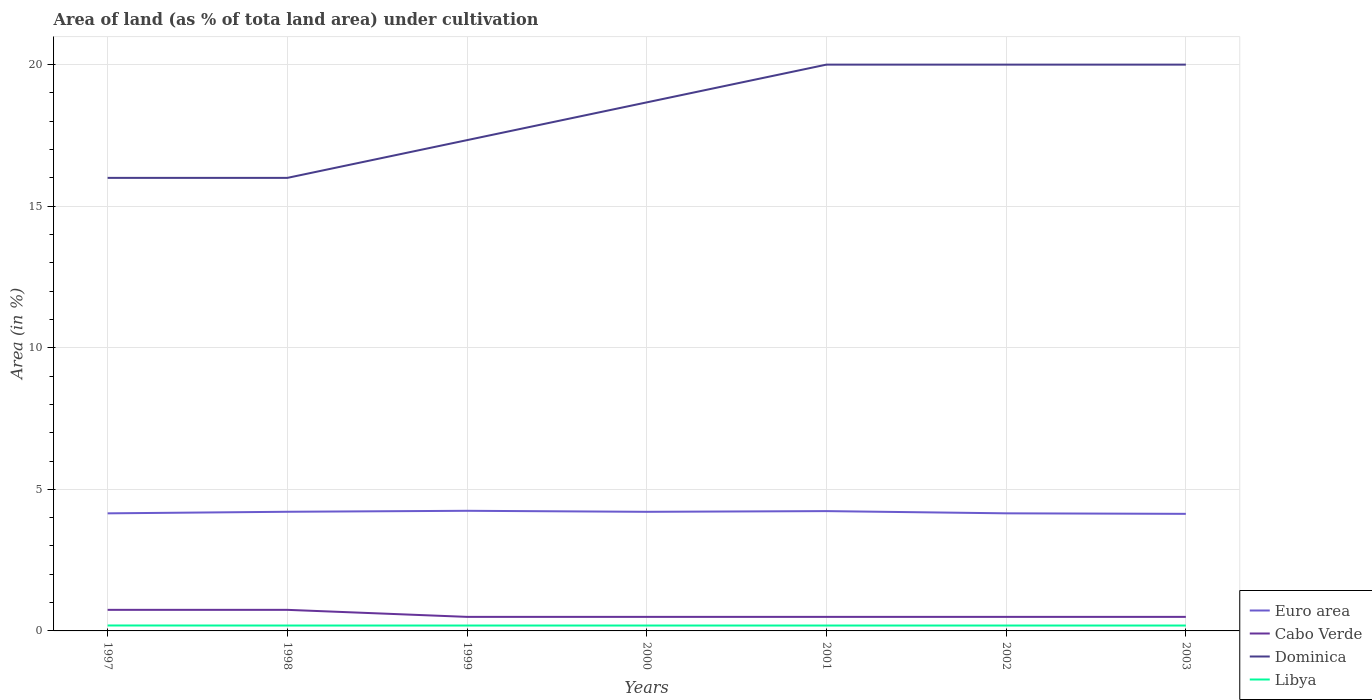Does the line corresponding to Dominica intersect with the line corresponding to Libya?
Your answer should be compact. No. Is the number of lines equal to the number of legend labels?
Offer a very short reply. Yes. Across all years, what is the maximum percentage of land under cultivation in Libya?
Your answer should be compact. 0.19. What is the total percentage of land under cultivation in Euro area in the graph?
Provide a succinct answer. -0.09. What is the difference between the highest and the second highest percentage of land under cultivation in Libya?
Offer a very short reply. 0. What is the difference between the highest and the lowest percentage of land under cultivation in Euro area?
Your answer should be very brief. 4. Is the percentage of land under cultivation in Euro area strictly greater than the percentage of land under cultivation in Libya over the years?
Your response must be concise. No. What is the difference between two consecutive major ticks on the Y-axis?
Keep it short and to the point. 5. Are the values on the major ticks of Y-axis written in scientific E-notation?
Your answer should be compact. No. Does the graph contain any zero values?
Your response must be concise. No. Does the graph contain grids?
Offer a very short reply. Yes. How many legend labels are there?
Provide a succinct answer. 4. What is the title of the graph?
Provide a short and direct response. Area of land (as % of tota land area) under cultivation. Does "Isle of Man" appear as one of the legend labels in the graph?
Offer a very short reply. No. What is the label or title of the X-axis?
Your answer should be very brief. Years. What is the label or title of the Y-axis?
Provide a short and direct response. Area (in %). What is the Area (in %) of Euro area in 1997?
Give a very brief answer. 4.15. What is the Area (in %) of Cabo Verde in 1997?
Offer a very short reply. 0.74. What is the Area (in %) of Dominica in 1997?
Offer a terse response. 16. What is the Area (in %) of Libya in 1997?
Ensure brevity in your answer.  0.19. What is the Area (in %) of Euro area in 1998?
Ensure brevity in your answer.  4.21. What is the Area (in %) in Cabo Verde in 1998?
Your response must be concise. 0.74. What is the Area (in %) in Dominica in 1998?
Ensure brevity in your answer.  16. What is the Area (in %) of Libya in 1998?
Offer a very short reply. 0.19. What is the Area (in %) in Euro area in 1999?
Your response must be concise. 4.24. What is the Area (in %) in Cabo Verde in 1999?
Give a very brief answer. 0.5. What is the Area (in %) in Dominica in 1999?
Offer a very short reply. 17.33. What is the Area (in %) of Libya in 1999?
Provide a succinct answer. 0.19. What is the Area (in %) in Euro area in 2000?
Offer a terse response. 4.21. What is the Area (in %) in Cabo Verde in 2000?
Your answer should be compact. 0.5. What is the Area (in %) in Dominica in 2000?
Provide a succinct answer. 18.67. What is the Area (in %) in Libya in 2000?
Your response must be concise. 0.19. What is the Area (in %) in Euro area in 2001?
Keep it short and to the point. 4.23. What is the Area (in %) of Cabo Verde in 2001?
Make the answer very short. 0.5. What is the Area (in %) of Libya in 2001?
Offer a very short reply. 0.19. What is the Area (in %) of Euro area in 2002?
Your answer should be very brief. 4.15. What is the Area (in %) of Cabo Verde in 2002?
Make the answer very short. 0.5. What is the Area (in %) in Libya in 2002?
Offer a very short reply. 0.19. What is the Area (in %) in Euro area in 2003?
Your answer should be compact. 4.14. What is the Area (in %) in Cabo Verde in 2003?
Keep it short and to the point. 0.5. What is the Area (in %) in Libya in 2003?
Provide a short and direct response. 0.19. Across all years, what is the maximum Area (in %) in Euro area?
Offer a very short reply. 4.24. Across all years, what is the maximum Area (in %) in Cabo Verde?
Offer a very short reply. 0.74. Across all years, what is the maximum Area (in %) of Libya?
Provide a short and direct response. 0.19. Across all years, what is the minimum Area (in %) in Euro area?
Keep it short and to the point. 4.14. Across all years, what is the minimum Area (in %) of Cabo Verde?
Provide a succinct answer. 0.5. Across all years, what is the minimum Area (in %) of Dominica?
Provide a short and direct response. 16. Across all years, what is the minimum Area (in %) of Libya?
Make the answer very short. 0.19. What is the total Area (in %) of Euro area in the graph?
Your response must be concise. 29.33. What is the total Area (in %) of Cabo Verde in the graph?
Your answer should be very brief. 3.97. What is the total Area (in %) of Dominica in the graph?
Provide a succinct answer. 128. What is the total Area (in %) in Libya in the graph?
Offer a very short reply. 1.33. What is the difference between the Area (in %) in Euro area in 1997 and that in 1998?
Offer a very short reply. -0.06. What is the difference between the Area (in %) of Libya in 1997 and that in 1998?
Your answer should be compact. 0. What is the difference between the Area (in %) in Euro area in 1997 and that in 1999?
Provide a succinct answer. -0.09. What is the difference between the Area (in %) of Cabo Verde in 1997 and that in 1999?
Offer a very short reply. 0.25. What is the difference between the Area (in %) of Dominica in 1997 and that in 1999?
Ensure brevity in your answer.  -1.33. What is the difference between the Area (in %) of Libya in 1997 and that in 1999?
Offer a very short reply. 0. What is the difference between the Area (in %) in Euro area in 1997 and that in 2000?
Make the answer very short. -0.05. What is the difference between the Area (in %) in Cabo Verde in 1997 and that in 2000?
Offer a very short reply. 0.25. What is the difference between the Area (in %) of Dominica in 1997 and that in 2000?
Keep it short and to the point. -2.67. What is the difference between the Area (in %) in Libya in 1997 and that in 2000?
Keep it short and to the point. 0. What is the difference between the Area (in %) of Euro area in 1997 and that in 2001?
Your response must be concise. -0.08. What is the difference between the Area (in %) in Cabo Verde in 1997 and that in 2001?
Provide a short and direct response. 0.25. What is the difference between the Area (in %) in Dominica in 1997 and that in 2001?
Offer a very short reply. -4. What is the difference between the Area (in %) in Libya in 1997 and that in 2001?
Your response must be concise. 0. What is the difference between the Area (in %) in Euro area in 1997 and that in 2002?
Keep it short and to the point. -0. What is the difference between the Area (in %) of Cabo Verde in 1997 and that in 2002?
Your response must be concise. 0.25. What is the difference between the Area (in %) in Dominica in 1997 and that in 2002?
Your response must be concise. -4. What is the difference between the Area (in %) of Libya in 1997 and that in 2002?
Provide a short and direct response. 0. What is the difference between the Area (in %) in Euro area in 1997 and that in 2003?
Provide a short and direct response. 0.02. What is the difference between the Area (in %) in Cabo Verde in 1997 and that in 2003?
Make the answer very short. 0.25. What is the difference between the Area (in %) in Dominica in 1997 and that in 2003?
Give a very brief answer. -4. What is the difference between the Area (in %) of Libya in 1997 and that in 2003?
Offer a very short reply. 0. What is the difference between the Area (in %) in Euro area in 1998 and that in 1999?
Your answer should be very brief. -0.03. What is the difference between the Area (in %) in Cabo Verde in 1998 and that in 1999?
Give a very brief answer. 0.25. What is the difference between the Area (in %) of Dominica in 1998 and that in 1999?
Offer a very short reply. -1.33. What is the difference between the Area (in %) in Euro area in 1998 and that in 2000?
Offer a terse response. 0. What is the difference between the Area (in %) of Cabo Verde in 1998 and that in 2000?
Your answer should be very brief. 0.25. What is the difference between the Area (in %) in Dominica in 1998 and that in 2000?
Your response must be concise. -2.67. What is the difference between the Area (in %) of Libya in 1998 and that in 2000?
Offer a very short reply. 0. What is the difference between the Area (in %) in Euro area in 1998 and that in 2001?
Provide a short and direct response. -0.02. What is the difference between the Area (in %) in Cabo Verde in 1998 and that in 2001?
Your response must be concise. 0.25. What is the difference between the Area (in %) of Euro area in 1998 and that in 2002?
Offer a terse response. 0.06. What is the difference between the Area (in %) of Cabo Verde in 1998 and that in 2002?
Your answer should be very brief. 0.25. What is the difference between the Area (in %) in Euro area in 1998 and that in 2003?
Provide a succinct answer. 0.07. What is the difference between the Area (in %) of Cabo Verde in 1998 and that in 2003?
Your response must be concise. 0.25. What is the difference between the Area (in %) in Euro area in 1999 and that in 2000?
Your response must be concise. 0.04. What is the difference between the Area (in %) in Dominica in 1999 and that in 2000?
Your response must be concise. -1.33. What is the difference between the Area (in %) in Euro area in 1999 and that in 2001?
Make the answer very short. 0.01. What is the difference between the Area (in %) in Dominica in 1999 and that in 2001?
Ensure brevity in your answer.  -2.67. What is the difference between the Area (in %) in Libya in 1999 and that in 2001?
Give a very brief answer. 0. What is the difference between the Area (in %) of Euro area in 1999 and that in 2002?
Ensure brevity in your answer.  0.09. What is the difference between the Area (in %) in Cabo Verde in 1999 and that in 2002?
Make the answer very short. 0. What is the difference between the Area (in %) of Dominica in 1999 and that in 2002?
Offer a terse response. -2.67. What is the difference between the Area (in %) in Euro area in 1999 and that in 2003?
Ensure brevity in your answer.  0.11. What is the difference between the Area (in %) of Cabo Verde in 1999 and that in 2003?
Make the answer very short. 0. What is the difference between the Area (in %) of Dominica in 1999 and that in 2003?
Provide a succinct answer. -2.67. What is the difference between the Area (in %) of Libya in 1999 and that in 2003?
Ensure brevity in your answer.  0. What is the difference between the Area (in %) of Euro area in 2000 and that in 2001?
Ensure brevity in your answer.  -0.02. What is the difference between the Area (in %) in Cabo Verde in 2000 and that in 2001?
Keep it short and to the point. 0. What is the difference between the Area (in %) in Dominica in 2000 and that in 2001?
Make the answer very short. -1.33. What is the difference between the Area (in %) of Libya in 2000 and that in 2001?
Make the answer very short. 0. What is the difference between the Area (in %) of Euro area in 2000 and that in 2002?
Your response must be concise. 0.05. What is the difference between the Area (in %) of Cabo Verde in 2000 and that in 2002?
Provide a succinct answer. 0. What is the difference between the Area (in %) in Dominica in 2000 and that in 2002?
Your answer should be compact. -1.33. What is the difference between the Area (in %) of Euro area in 2000 and that in 2003?
Provide a short and direct response. 0.07. What is the difference between the Area (in %) in Cabo Verde in 2000 and that in 2003?
Provide a short and direct response. 0. What is the difference between the Area (in %) in Dominica in 2000 and that in 2003?
Ensure brevity in your answer.  -1.33. What is the difference between the Area (in %) of Euro area in 2001 and that in 2002?
Make the answer very short. 0.08. What is the difference between the Area (in %) of Dominica in 2001 and that in 2002?
Provide a succinct answer. 0. What is the difference between the Area (in %) in Libya in 2001 and that in 2002?
Keep it short and to the point. 0. What is the difference between the Area (in %) of Euro area in 2001 and that in 2003?
Keep it short and to the point. 0.1. What is the difference between the Area (in %) of Cabo Verde in 2001 and that in 2003?
Your response must be concise. 0. What is the difference between the Area (in %) in Euro area in 2002 and that in 2003?
Offer a very short reply. 0.02. What is the difference between the Area (in %) of Dominica in 2002 and that in 2003?
Provide a succinct answer. 0. What is the difference between the Area (in %) in Libya in 2002 and that in 2003?
Your answer should be very brief. 0. What is the difference between the Area (in %) of Euro area in 1997 and the Area (in %) of Cabo Verde in 1998?
Provide a succinct answer. 3.41. What is the difference between the Area (in %) in Euro area in 1997 and the Area (in %) in Dominica in 1998?
Your answer should be compact. -11.85. What is the difference between the Area (in %) of Euro area in 1997 and the Area (in %) of Libya in 1998?
Make the answer very short. 3.96. What is the difference between the Area (in %) of Cabo Verde in 1997 and the Area (in %) of Dominica in 1998?
Give a very brief answer. -15.26. What is the difference between the Area (in %) in Cabo Verde in 1997 and the Area (in %) in Libya in 1998?
Provide a short and direct response. 0.55. What is the difference between the Area (in %) in Dominica in 1997 and the Area (in %) in Libya in 1998?
Your answer should be very brief. 15.81. What is the difference between the Area (in %) in Euro area in 1997 and the Area (in %) in Cabo Verde in 1999?
Provide a succinct answer. 3.66. What is the difference between the Area (in %) in Euro area in 1997 and the Area (in %) in Dominica in 1999?
Provide a succinct answer. -13.18. What is the difference between the Area (in %) in Euro area in 1997 and the Area (in %) in Libya in 1999?
Offer a terse response. 3.96. What is the difference between the Area (in %) in Cabo Verde in 1997 and the Area (in %) in Dominica in 1999?
Offer a terse response. -16.59. What is the difference between the Area (in %) in Cabo Verde in 1997 and the Area (in %) in Libya in 1999?
Offer a terse response. 0.55. What is the difference between the Area (in %) of Dominica in 1997 and the Area (in %) of Libya in 1999?
Your answer should be very brief. 15.81. What is the difference between the Area (in %) in Euro area in 1997 and the Area (in %) in Cabo Verde in 2000?
Your answer should be very brief. 3.66. What is the difference between the Area (in %) of Euro area in 1997 and the Area (in %) of Dominica in 2000?
Offer a very short reply. -14.51. What is the difference between the Area (in %) in Euro area in 1997 and the Area (in %) in Libya in 2000?
Your answer should be very brief. 3.96. What is the difference between the Area (in %) of Cabo Verde in 1997 and the Area (in %) of Dominica in 2000?
Give a very brief answer. -17.92. What is the difference between the Area (in %) of Cabo Verde in 1997 and the Area (in %) of Libya in 2000?
Ensure brevity in your answer.  0.55. What is the difference between the Area (in %) in Dominica in 1997 and the Area (in %) in Libya in 2000?
Your answer should be very brief. 15.81. What is the difference between the Area (in %) in Euro area in 1997 and the Area (in %) in Cabo Verde in 2001?
Ensure brevity in your answer.  3.66. What is the difference between the Area (in %) in Euro area in 1997 and the Area (in %) in Dominica in 2001?
Provide a short and direct response. -15.85. What is the difference between the Area (in %) of Euro area in 1997 and the Area (in %) of Libya in 2001?
Provide a short and direct response. 3.96. What is the difference between the Area (in %) of Cabo Verde in 1997 and the Area (in %) of Dominica in 2001?
Offer a terse response. -19.26. What is the difference between the Area (in %) in Cabo Verde in 1997 and the Area (in %) in Libya in 2001?
Keep it short and to the point. 0.55. What is the difference between the Area (in %) of Dominica in 1997 and the Area (in %) of Libya in 2001?
Provide a short and direct response. 15.81. What is the difference between the Area (in %) in Euro area in 1997 and the Area (in %) in Cabo Verde in 2002?
Keep it short and to the point. 3.66. What is the difference between the Area (in %) of Euro area in 1997 and the Area (in %) of Dominica in 2002?
Your answer should be very brief. -15.85. What is the difference between the Area (in %) of Euro area in 1997 and the Area (in %) of Libya in 2002?
Provide a short and direct response. 3.96. What is the difference between the Area (in %) of Cabo Verde in 1997 and the Area (in %) of Dominica in 2002?
Keep it short and to the point. -19.26. What is the difference between the Area (in %) in Cabo Verde in 1997 and the Area (in %) in Libya in 2002?
Offer a terse response. 0.55. What is the difference between the Area (in %) in Dominica in 1997 and the Area (in %) in Libya in 2002?
Offer a very short reply. 15.81. What is the difference between the Area (in %) in Euro area in 1997 and the Area (in %) in Cabo Verde in 2003?
Offer a terse response. 3.66. What is the difference between the Area (in %) of Euro area in 1997 and the Area (in %) of Dominica in 2003?
Keep it short and to the point. -15.85. What is the difference between the Area (in %) in Euro area in 1997 and the Area (in %) in Libya in 2003?
Make the answer very short. 3.96. What is the difference between the Area (in %) in Cabo Verde in 1997 and the Area (in %) in Dominica in 2003?
Your answer should be compact. -19.26. What is the difference between the Area (in %) in Cabo Verde in 1997 and the Area (in %) in Libya in 2003?
Offer a terse response. 0.55. What is the difference between the Area (in %) in Dominica in 1997 and the Area (in %) in Libya in 2003?
Ensure brevity in your answer.  15.81. What is the difference between the Area (in %) of Euro area in 1998 and the Area (in %) of Cabo Verde in 1999?
Ensure brevity in your answer.  3.71. What is the difference between the Area (in %) of Euro area in 1998 and the Area (in %) of Dominica in 1999?
Give a very brief answer. -13.12. What is the difference between the Area (in %) in Euro area in 1998 and the Area (in %) in Libya in 1999?
Your response must be concise. 4.02. What is the difference between the Area (in %) of Cabo Verde in 1998 and the Area (in %) of Dominica in 1999?
Your response must be concise. -16.59. What is the difference between the Area (in %) in Cabo Verde in 1998 and the Area (in %) in Libya in 1999?
Offer a terse response. 0.55. What is the difference between the Area (in %) in Dominica in 1998 and the Area (in %) in Libya in 1999?
Provide a succinct answer. 15.81. What is the difference between the Area (in %) of Euro area in 1998 and the Area (in %) of Cabo Verde in 2000?
Make the answer very short. 3.71. What is the difference between the Area (in %) in Euro area in 1998 and the Area (in %) in Dominica in 2000?
Keep it short and to the point. -14.46. What is the difference between the Area (in %) in Euro area in 1998 and the Area (in %) in Libya in 2000?
Make the answer very short. 4.02. What is the difference between the Area (in %) of Cabo Verde in 1998 and the Area (in %) of Dominica in 2000?
Offer a terse response. -17.92. What is the difference between the Area (in %) in Cabo Verde in 1998 and the Area (in %) in Libya in 2000?
Make the answer very short. 0.55. What is the difference between the Area (in %) of Dominica in 1998 and the Area (in %) of Libya in 2000?
Your answer should be very brief. 15.81. What is the difference between the Area (in %) in Euro area in 1998 and the Area (in %) in Cabo Verde in 2001?
Provide a short and direct response. 3.71. What is the difference between the Area (in %) in Euro area in 1998 and the Area (in %) in Dominica in 2001?
Provide a short and direct response. -15.79. What is the difference between the Area (in %) of Euro area in 1998 and the Area (in %) of Libya in 2001?
Offer a terse response. 4.02. What is the difference between the Area (in %) in Cabo Verde in 1998 and the Area (in %) in Dominica in 2001?
Your response must be concise. -19.26. What is the difference between the Area (in %) of Cabo Verde in 1998 and the Area (in %) of Libya in 2001?
Make the answer very short. 0.55. What is the difference between the Area (in %) of Dominica in 1998 and the Area (in %) of Libya in 2001?
Your answer should be compact. 15.81. What is the difference between the Area (in %) in Euro area in 1998 and the Area (in %) in Cabo Verde in 2002?
Provide a succinct answer. 3.71. What is the difference between the Area (in %) of Euro area in 1998 and the Area (in %) of Dominica in 2002?
Your answer should be very brief. -15.79. What is the difference between the Area (in %) of Euro area in 1998 and the Area (in %) of Libya in 2002?
Your answer should be compact. 4.02. What is the difference between the Area (in %) of Cabo Verde in 1998 and the Area (in %) of Dominica in 2002?
Provide a short and direct response. -19.26. What is the difference between the Area (in %) in Cabo Verde in 1998 and the Area (in %) in Libya in 2002?
Offer a terse response. 0.55. What is the difference between the Area (in %) of Dominica in 1998 and the Area (in %) of Libya in 2002?
Your response must be concise. 15.81. What is the difference between the Area (in %) of Euro area in 1998 and the Area (in %) of Cabo Verde in 2003?
Offer a very short reply. 3.71. What is the difference between the Area (in %) of Euro area in 1998 and the Area (in %) of Dominica in 2003?
Your answer should be very brief. -15.79. What is the difference between the Area (in %) in Euro area in 1998 and the Area (in %) in Libya in 2003?
Your answer should be compact. 4.02. What is the difference between the Area (in %) of Cabo Verde in 1998 and the Area (in %) of Dominica in 2003?
Offer a terse response. -19.26. What is the difference between the Area (in %) in Cabo Verde in 1998 and the Area (in %) in Libya in 2003?
Offer a terse response. 0.55. What is the difference between the Area (in %) of Dominica in 1998 and the Area (in %) of Libya in 2003?
Your response must be concise. 15.81. What is the difference between the Area (in %) in Euro area in 1999 and the Area (in %) in Cabo Verde in 2000?
Provide a short and direct response. 3.75. What is the difference between the Area (in %) of Euro area in 1999 and the Area (in %) of Dominica in 2000?
Make the answer very short. -14.42. What is the difference between the Area (in %) of Euro area in 1999 and the Area (in %) of Libya in 2000?
Make the answer very short. 4.05. What is the difference between the Area (in %) in Cabo Verde in 1999 and the Area (in %) in Dominica in 2000?
Make the answer very short. -18.17. What is the difference between the Area (in %) of Cabo Verde in 1999 and the Area (in %) of Libya in 2000?
Give a very brief answer. 0.31. What is the difference between the Area (in %) of Dominica in 1999 and the Area (in %) of Libya in 2000?
Keep it short and to the point. 17.14. What is the difference between the Area (in %) of Euro area in 1999 and the Area (in %) of Cabo Verde in 2001?
Ensure brevity in your answer.  3.75. What is the difference between the Area (in %) of Euro area in 1999 and the Area (in %) of Dominica in 2001?
Provide a succinct answer. -15.76. What is the difference between the Area (in %) of Euro area in 1999 and the Area (in %) of Libya in 2001?
Your answer should be very brief. 4.05. What is the difference between the Area (in %) in Cabo Verde in 1999 and the Area (in %) in Dominica in 2001?
Ensure brevity in your answer.  -19.5. What is the difference between the Area (in %) in Cabo Verde in 1999 and the Area (in %) in Libya in 2001?
Offer a very short reply. 0.31. What is the difference between the Area (in %) in Dominica in 1999 and the Area (in %) in Libya in 2001?
Ensure brevity in your answer.  17.14. What is the difference between the Area (in %) in Euro area in 1999 and the Area (in %) in Cabo Verde in 2002?
Keep it short and to the point. 3.75. What is the difference between the Area (in %) in Euro area in 1999 and the Area (in %) in Dominica in 2002?
Provide a short and direct response. -15.76. What is the difference between the Area (in %) of Euro area in 1999 and the Area (in %) of Libya in 2002?
Keep it short and to the point. 4.05. What is the difference between the Area (in %) of Cabo Verde in 1999 and the Area (in %) of Dominica in 2002?
Your response must be concise. -19.5. What is the difference between the Area (in %) in Cabo Verde in 1999 and the Area (in %) in Libya in 2002?
Give a very brief answer. 0.31. What is the difference between the Area (in %) in Dominica in 1999 and the Area (in %) in Libya in 2002?
Offer a terse response. 17.14. What is the difference between the Area (in %) of Euro area in 1999 and the Area (in %) of Cabo Verde in 2003?
Make the answer very short. 3.75. What is the difference between the Area (in %) of Euro area in 1999 and the Area (in %) of Dominica in 2003?
Provide a short and direct response. -15.76. What is the difference between the Area (in %) in Euro area in 1999 and the Area (in %) in Libya in 2003?
Keep it short and to the point. 4.05. What is the difference between the Area (in %) in Cabo Verde in 1999 and the Area (in %) in Dominica in 2003?
Your response must be concise. -19.5. What is the difference between the Area (in %) in Cabo Verde in 1999 and the Area (in %) in Libya in 2003?
Your answer should be very brief. 0.31. What is the difference between the Area (in %) in Dominica in 1999 and the Area (in %) in Libya in 2003?
Your response must be concise. 17.14. What is the difference between the Area (in %) of Euro area in 2000 and the Area (in %) of Cabo Verde in 2001?
Your answer should be very brief. 3.71. What is the difference between the Area (in %) in Euro area in 2000 and the Area (in %) in Dominica in 2001?
Your response must be concise. -15.79. What is the difference between the Area (in %) of Euro area in 2000 and the Area (in %) of Libya in 2001?
Your response must be concise. 4.02. What is the difference between the Area (in %) in Cabo Verde in 2000 and the Area (in %) in Dominica in 2001?
Offer a terse response. -19.5. What is the difference between the Area (in %) in Cabo Verde in 2000 and the Area (in %) in Libya in 2001?
Provide a succinct answer. 0.31. What is the difference between the Area (in %) in Dominica in 2000 and the Area (in %) in Libya in 2001?
Keep it short and to the point. 18.48. What is the difference between the Area (in %) of Euro area in 2000 and the Area (in %) of Cabo Verde in 2002?
Offer a very short reply. 3.71. What is the difference between the Area (in %) of Euro area in 2000 and the Area (in %) of Dominica in 2002?
Keep it short and to the point. -15.79. What is the difference between the Area (in %) in Euro area in 2000 and the Area (in %) in Libya in 2002?
Give a very brief answer. 4.02. What is the difference between the Area (in %) of Cabo Verde in 2000 and the Area (in %) of Dominica in 2002?
Offer a very short reply. -19.5. What is the difference between the Area (in %) of Cabo Verde in 2000 and the Area (in %) of Libya in 2002?
Your answer should be compact. 0.31. What is the difference between the Area (in %) in Dominica in 2000 and the Area (in %) in Libya in 2002?
Your answer should be compact. 18.48. What is the difference between the Area (in %) of Euro area in 2000 and the Area (in %) of Cabo Verde in 2003?
Your answer should be compact. 3.71. What is the difference between the Area (in %) in Euro area in 2000 and the Area (in %) in Dominica in 2003?
Your answer should be very brief. -15.79. What is the difference between the Area (in %) in Euro area in 2000 and the Area (in %) in Libya in 2003?
Offer a very short reply. 4.02. What is the difference between the Area (in %) in Cabo Verde in 2000 and the Area (in %) in Dominica in 2003?
Make the answer very short. -19.5. What is the difference between the Area (in %) in Cabo Verde in 2000 and the Area (in %) in Libya in 2003?
Ensure brevity in your answer.  0.31. What is the difference between the Area (in %) in Dominica in 2000 and the Area (in %) in Libya in 2003?
Offer a very short reply. 18.48. What is the difference between the Area (in %) in Euro area in 2001 and the Area (in %) in Cabo Verde in 2002?
Give a very brief answer. 3.74. What is the difference between the Area (in %) of Euro area in 2001 and the Area (in %) of Dominica in 2002?
Give a very brief answer. -15.77. What is the difference between the Area (in %) of Euro area in 2001 and the Area (in %) of Libya in 2002?
Provide a succinct answer. 4.04. What is the difference between the Area (in %) in Cabo Verde in 2001 and the Area (in %) in Dominica in 2002?
Your answer should be compact. -19.5. What is the difference between the Area (in %) in Cabo Verde in 2001 and the Area (in %) in Libya in 2002?
Your answer should be very brief. 0.31. What is the difference between the Area (in %) in Dominica in 2001 and the Area (in %) in Libya in 2002?
Give a very brief answer. 19.81. What is the difference between the Area (in %) of Euro area in 2001 and the Area (in %) of Cabo Verde in 2003?
Your answer should be very brief. 3.74. What is the difference between the Area (in %) of Euro area in 2001 and the Area (in %) of Dominica in 2003?
Your answer should be very brief. -15.77. What is the difference between the Area (in %) in Euro area in 2001 and the Area (in %) in Libya in 2003?
Your answer should be very brief. 4.04. What is the difference between the Area (in %) of Cabo Verde in 2001 and the Area (in %) of Dominica in 2003?
Give a very brief answer. -19.5. What is the difference between the Area (in %) of Cabo Verde in 2001 and the Area (in %) of Libya in 2003?
Keep it short and to the point. 0.31. What is the difference between the Area (in %) in Dominica in 2001 and the Area (in %) in Libya in 2003?
Provide a short and direct response. 19.81. What is the difference between the Area (in %) in Euro area in 2002 and the Area (in %) in Cabo Verde in 2003?
Your answer should be compact. 3.66. What is the difference between the Area (in %) in Euro area in 2002 and the Area (in %) in Dominica in 2003?
Keep it short and to the point. -15.85. What is the difference between the Area (in %) of Euro area in 2002 and the Area (in %) of Libya in 2003?
Your answer should be very brief. 3.96. What is the difference between the Area (in %) in Cabo Verde in 2002 and the Area (in %) in Dominica in 2003?
Make the answer very short. -19.5. What is the difference between the Area (in %) of Cabo Verde in 2002 and the Area (in %) of Libya in 2003?
Provide a succinct answer. 0.31. What is the difference between the Area (in %) of Dominica in 2002 and the Area (in %) of Libya in 2003?
Your answer should be very brief. 19.81. What is the average Area (in %) in Euro area per year?
Give a very brief answer. 4.19. What is the average Area (in %) in Cabo Verde per year?
Keep it short and to the point. 0.57. What is the average Area (in %) of Dominica per year?
Provide a short and direct response. 18.29. What is the average Area (in %) in Libya per year?
Keep it short and to the point. 0.19. In the year 1997, what is the difference between the Area (in %) of Euro area and Area (in %) of Cabo Verde?
Your answer should be compact. 3.41. In the year 1997, what is the difference between the Area (in %) of Euro area and Area (in %) of Dominica?
Provide a succinct answer. -11.85. In the year 1997, what is the difference between the Area (in %) in Euro area and Area (in %) in Libya?
Your answer should be very brief. 3.96. In the year 1997, what is the difference between the Area (in %) of Cabo Verde and Area (in %) of Dominica?
Your answer should be compact. -15.26. In the year 1997, what is the difference between the Area (in %) in Cabo Verde and Area (in %) in Libya?
Provide a short and direct response. 0.55. In the year 1997, what is the difference between the Area (in %) in Dominica and Area (in %) in Libya?
Give a very brief answer. 15.81. In the year 1998, what is the difference between the Area (in %) in Euro area and Area (in %) in Cabo Verde?
Your answer should be very brief. 3.46. In the year 1998, what is the difference between the Area (in %) of Euro area and Area (in %) of Dominica?
Provide a succinct answer. -11.79. In the year 1998, what is the difference between the Area (in %) of Euro area and Area (in %) of Libya?
Make the answer very short. 4.02. In the year 1998, what is the difference between the Area (in %) in Cabo Verde and Area (in %) in Dominica?
Your answer should be compact. -15.26. In the year 1998, what is the difference between the Area (in %) of Cabo Verde and Area (in %) of Libya?
Provide a succinct answer. 0.55. In the year 1998, what is the difference between the Area (in %) in Dominica and Area (in %) in Libya?
Ensure brevity in your answer.  15.81. In the year 1999, what is the difference between the Area (in %) of Euro area and Area (in %) of Cabo Verde?
Give a very brief answer. 3.75. In the year 1999, what is the difference between the Area (in %) of Euro area and Area (in %) of Dominica?
Your answer should be compact. -13.09. In the year 1999, what is the difference between the Area (in %) in Euro area and Area (in %) in Libya?
Give a very brief answer. 4.05. In the year 1999, what is the difference between the Area (in %) of Cabo Verde and Area (in %) of Dominica?
Keep it short and to the point. -16.84. In the year 1999, what is the difference between the Area (in %) in Cabo Verde and Area (in %) in Libya?
Your answer should be very brief. 0.31. In the year 1999, what is the difference between the Area (in %) of Dominica and Area (in %) of Libya?
Your answer should be compact. 17.14. In the year 2000, what is the difference between the Area (in %) of Euro area and Area (in %) of Cabo Verde?
Ensure brevity in your answer.  3.71. In the year 2000, what is the difference between the Area (in %) in Euro area and Area (in %) in Dominica?
Give a very brief answer. -14.46. In the year 2000, what is the difference between the Area (in %) of Euro area and Area (in %) of Libya?
Offer a very short reply. 4.02. In the year 2000, what is the difference between the Area (in %) in Cabo Verde and Area (in %) in Dominica?
Offer a terse response. -18.17. In the year 2000, what is the difference between the Area (in %) in Cabo Verde and Area (in %) in Libya?
Keep it short and to the point. 0.31. In the year 2000, what is the difference between the Area (in %) of Dominica and Area (in %) of Libya?
Your response must be concise. 18.48. In the year 2001, what is the difference between the Area (in %) in Euro area and Area (in %) in Cabo Verde?
Ensure brevity in your answer.  3.74. In the year 2001, what is the difference between the Area (in %) in Euro area and Area (in %) in Dominica?
Give a very brief answer. -15.77. In the year 2001, what is the difference between the Area (in %) of Euro area and Area (in %) of Libya?
Provide a succinct answer. 4.04. In the year 2001, what is the difference between the Area (in %) in Cabo Verde and Area (in %) in Dominica?
Offer a very short reply. -19.5. In the year 2001, what is the difference between the Area (in %) in Cabo Verde and Area (in %) in Libya?
Your response must be concise. 0.31. In the year 2001, what is the difference between the Area (in %) in Dominica and Area (in %) in Libya?
Offer a terse response. 19.81. In the year 2002, what is the difference between the Area (in %) in Euro area and Area (in %) in Cabo Verde?
Ensure brevity in your answer.  3.66. In the year 2002, what is the difference between the Area (in %) of Euro area and Area (in %) of Dominica?
Your answer should be compact. -15.85. In the year 2002, what is the difference between the Area (in %) in Euro area and Area (in %) in Libya?
Your response must be concise. 3.96. In the year 2002, what is the difference between the Area (in %) in Cabo Verde and Area (in %) in Dominica?
Keep it short and to the point. -19.5. In the year 2002, what is the difference between the Area (in %) of Cabo Verde and Area (in %) of Libya?
Your response must be concise. 0.31. In the year 2002, what is the difference between the Area (in %) of Dominica and Area (in %) of Libya?
Ensure brevity in your answer.  19.81. In the year 2003, what is the difference between the Area (in %) of Euro area and Area (in %) of Cabo Verde?
Provide a succinct answer. 3.64. In the year 2003, what is the difference between the Area (in %) of Euro area and Area (in %) of Dominica?
Ensure brevity in your answer.  -15.86. In the year 2003, what is the difference between the Area (in %) in Euro area and Area (in %) in Libya?
Keep it short and to the point. 3.94. In the year 2003, what is the difference between the Area (in %) in Cabo Verde and Area (in %) in Dominica?
Give a very brief answer. -19.5. In the year 2003, what is the difference between the Area (in %) in Cabo Verde and Area (in %) in Libya?
Keep it short and to the point. 0.31. In the year 2003, what is the difference between the Area (in %) in Dominica and Area (in %) in Libya?
Provide a short and direct response. 19.81. What is the ratio of the Area (in %) of Euro area in 1997 to that in 1998?
Offer a terse response. 0.99. What is the ratio of the Area (in %) in Cabo Verde in 1997 to that in 1998?
Provide a succinct answer. 1. What is the ratio of the Area (in %) of Dominica in 1997 to that in 1998?
Ensure brevity in your answer.  1. What is the ratio of the Area (in %) in Euro area in 1997 to that in 1999?
Offer a terse response. 0.98. What is the ratio of the Area (in %) of Cabo Verde in 1997 to that in 1999?
Ensure brevity in your answer.  1.5. What is the ratio of the Area (in %) of Dominica in 1997 to that in 1999?
Your answer should be compact. 0.92. What is the ratio of the Area (in %) of Euro area in 1997 to that in 2000?
Your answer should be very brief. 0.99. What is the ratio of the Area (in %) of Cabo Verde in 1997 to that in 2000?
Your answer should be compact. 1.5. What is the ratio of the Area (in %) in Dominica in 1997 to that in 2000?
Your answer should be compact. 0.86. What is the ratio of the Area (in %) in Euro area in 1997 to that in 2001?
Keep it short and to the point. 0.98. What is the ratio of the Area (in %) in Cabo Verde in 1997 to that in 2001?
Provide a succinct answer. 1.5. What is the ratio of the Area (in %) in Libya in 1997 to that in 2001?
Your answer should be very brief. 1.01. What is the ratio of the Area (in %) in Cabo Verde in 1997 to that in 2002?
Make the answer very short. 1.5. What is the ratio of the Area (in %) of Dominica in 1997 to that in 2003?
Ensure brevity in your answer.  0.8. What is the ratio of the Area (in %) of Libya in 1997 to that in 2003?
Make the answer very short. 1.01. What is the ratio of the Area (in %) in Cabo Verde in 1998 to that in 1999?
Your answer should be very brief. 1.5. What is the ratio of the Area (in %) of Dominica in 1998 to that in 1999?
Make the answer very short. 0.92. What is the ratio of the Area (in %) in Dominica in 1998 to that in 2000?
Ensure brevity in your answer.  0.86. What is the ratio of the Area (in %) in Libya in 1998 to that in 2000?
Keep it short and to the point. 1. What is the ratio of the Area (in %) in Euro area in 1998 to that in 2001?
Your answer should be very brief. 0.99. What is the ratio of the Area (in %) in Cabo Verde in 1998 to that in 2001?
Keep it short and to the point. 1.5. What is the ratio of the Area (in %) in Libya in 1998 to that in 2001?
Offer a very short reply. 1. What is the ratio of the Area (in %) of Euro area in 1998 to that in 2002?
Provide a short and direct response. 1.01. What is the ratio of the Area (in %) in Cabo Verde in 1998 to that in 2002?
Keep it short and to the point. 1.5. What is the ratio of the Area (in %) of Euro area in 1998 to that in 2003?
Make the answer very short. 1.02. What is the ratio of the Area (in %) of Libya in 1998 to that in 2003?
Keep it short and to the point. 1. What is the ratio of the Area (in %) in Euro area in 1999 to that in 2000?
Give a very brief answer. 1.01. What is the ratio of the Area (in %) in Cabo Verde in 1999 to that in 2000?
Offer a terse response. 1. What is the ratio of the Area (in %) of Dominica in 1999 to that in 2000?
Provide a short and direct response. 0.93. What is the ratio of the Area (in %) in Libya in 1999 to that in 2000?
Offer a very short reply. 1. What is the ratio of the Area (in %) in Dominica in 1999 to that in 2001?
Offer a very short reply. 0.87. What is the ratio of the Area (in %) in Euro area in 1999 to that in 2002?
Give a very brief answer. 1.02. What is the ratio of the Area (in %) in Cabo Verde in 1999 to that in 2002?
Give a very brief answer. 1. What is the ratio of the Area (in %) in Dominica in 1999 to that in 2002?
Offer a terse response. 0.87. What is the ratio of the Area (in %) of Euro area in 1999 to that in 2003?
Your response must be concise. 1.03. What is the ratio of the Area (in %) of Dominica in 1999 to that in 2003?
Provide a short and direct response. 0.87. What is the ratio of the Area (in %) of Libya in 1999 to that in 2003?
Your answer should be compact. 1. What is the ratio of the Area (in %) of Euro area in 2000 to that in 2001?
Make the answer very short. 0.99. What is the ratio of the Area (in %) in Libya in 2000 to that in 2001?
Make the answer very short. 1. What is the ratio of the Area (in %) of Cabo Verde in 2000 to that in 2002?
Your answer should be compact. 1. What is the ratio of the Area (in %) in Libya in 2000 to that in 2002?
Make the answer very short. 1. What is the ratio of the Area (in %) of Euro area in 2000 to that in 2003?
Keep it short and to the point. 1.02. What is the ratio of the Area (in %) of Dominica in 2000 to that in 2003?
Provide a succinct answer. 0.93. What is the ratio of the Area (in %) of Euro area in 2001 to that in 2002?
Offer a terse response. 1.02. What is the ratio of the Area (in %) in Euro area in 2001 to that in 2003?
Ensure brevity in your answer.  1.02. What is the ratio of the Area (in %) in Cabo Verde in 2001 to that in 2003?
Your answer should be very brief. 1. What is the ratio of the Area (in %) of Libya in 2001 to that in 2003?
Your response must be concise. 1. What is the ratio of the Area (in %) of Libya in 2002 to that in 2003?
Make the answer very short. 1. What is the difference between the highest and the second highest Area (in %) of Euro area?
Provide a short and direct response. 0.01. What is the difference between the highest and the second highest Area (in %) of Cabo Verde?
Offer a terse response. 0. What is the difference between the highest and the second highest Area (in %) in Dominica?
Your answer should be compact. 0. What is the difference between the highest and the second highest Area (in %) in Libya?
Offer a very short reply. 0. What is the difference between the highest and the lowest Area (in %) of Euro area?
Ensure brevity in your answer.  0.11. What is the difference between the highest and the lowest Area (in %) in Cabo Verde?
Provide a short and direct response. 0.25. What is the difference between the highest and the lowest Area (in %) of Dominica?
Offer a terse response. 4. What is the difference between the highest and the lowest Area (in %) in Libya?
Offer a terse response. 0. 